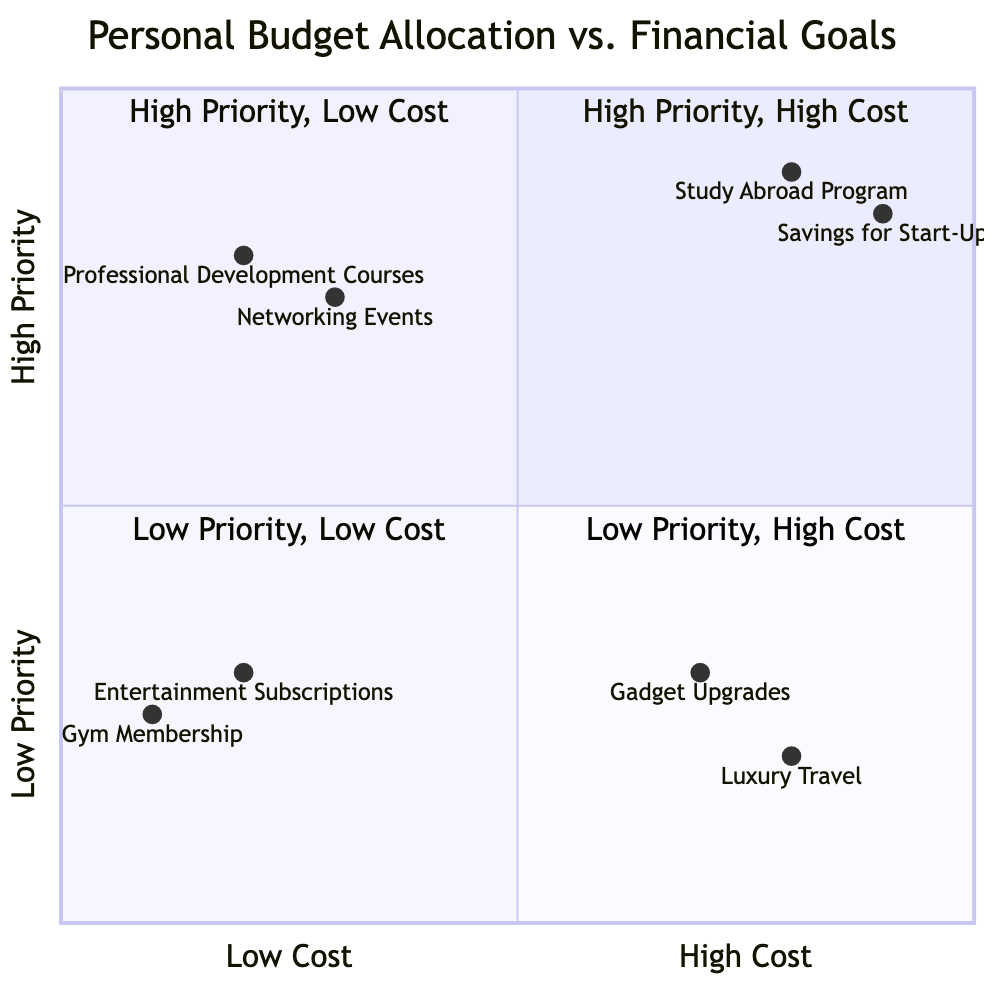What are the two elements in the "High Priority, High Cost" quadrant? The "High Priority, High Cost" quadrant includes "Study Abroad Program" and "Savings for Start-Up". These elements represent significant financial goals that are also prioritized highly.
Answer: Study Abroad Program, Savings for Start-Up How many elements are in the "Low Priority, High Cost" quadrant? The "Low Priority, High Cost" quadrant contains two elements, "Gadget Upgrades" and "Luxury Travel", both of which are considered less important relative to others but more expensive.
Answer: 2 Which element is positioned in the "High Priority, Low Cost" quadrant? The elements located in the "High Priority, Low Cost" quadrant are "Professional Development Courses" and "Networking Events". These are critical for future opportunities but do not incur high expenses.
Answer: Professional Development Courses, Networking Events What is the common characteristic of the "Low Priority, Low Cost" quadrant? The "Low Priority, Low Cost" quadrant includes activities that are inexpensive, such as "Entertainment Subscriptions" and "Gym Membership", which generally do not contribute significantly towards major financial goals.
Answer: Inexpensive activities Which quadrant has elements with the highest overall cost? The "High Priority, High Cost" quadrant contains the elements representing the highest costs, specifically for goals that hold significant importance like education and entrepreneurship.
Answer: High Priority, High Cost If I prioritize "Study Abroad Program" over "Gadget Upgrades", which quadrant do these elements belong to? "Study Abroad Program" belongs to the "High Priority, High Cost" quadrant, while "Gadget Upgrades" is located in the "Low Priority, High Cost" quadrant. The question highlights that the prioritization aligns with the elements' respective quadrants.
Answer: High Priority, High Cost, Low Priority, High Cost How does "Savings for Start-Up" compare to "Professional Development Courses" regarding cost and priority? "Savings for Start-Up" is considered high priority and high cost, whereas "Professional Development Courses" are high priority but low cost, illustrating a difference in financial impact despite similar priorities.
Answer: High cost vs. low cost 